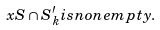Convert formula to latex. <formula><loc_0><loc_0><loc_500><loc_500>x S \cap S ^ { \prime } _ { k } i s n o n e m p t y .</formula> 